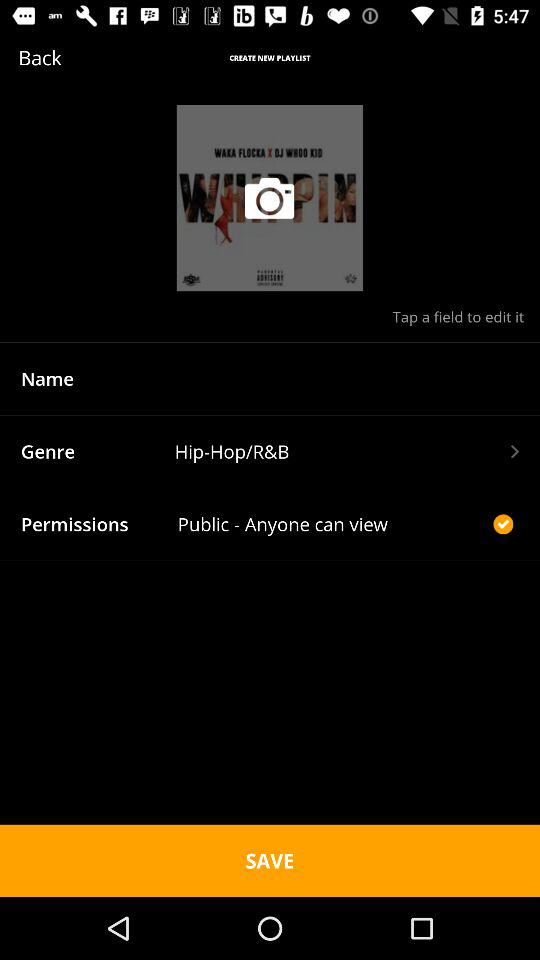What is the genre? The genre is "Hip-Hop/R&B". 